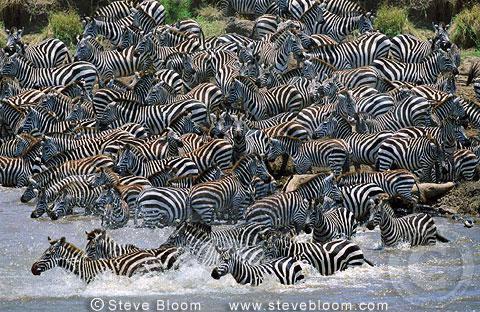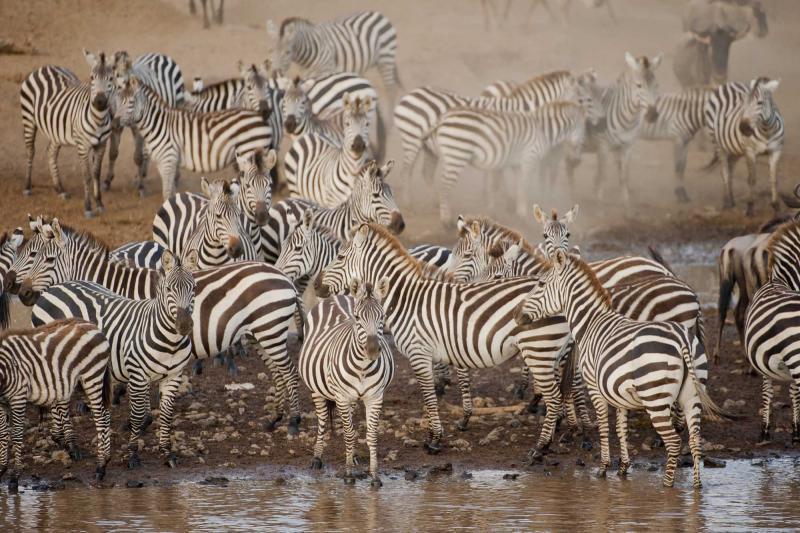The first image is the image on the left, the second image is the image on the right. Evaluate the accuracy of this statement regarding the images: "One image shows a row of zebras standing in water with heads lowered to drink.". Is it true? Answer yes or no. No. The first image is the image on the left, the second image is the image on the right. Assess this claim about the two images: "The animals in both images are near a body of water.". Correct or not? Answer yes or no. Yes. 